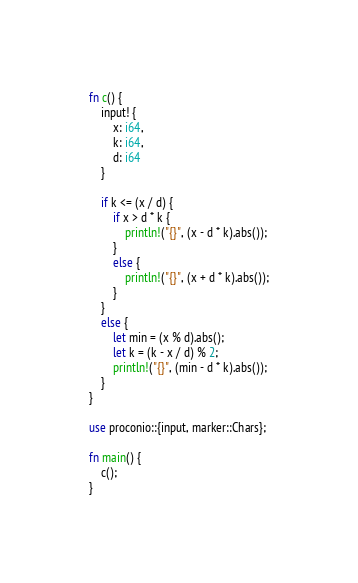Convert code to text. <code><loc_0><loc_0><loc_500><loc_500><_Rust_>fn c() {
    input! {
        x: i64,
        k: i64,
        d: i64
    }

    if k <= (x / d) {
        if x > d * k {
            println!("{}", (x - d * k).abs());
        }
        else {
            println!("{}", (x + d * k).abs());
        }
    }
    else {
        let min = (x % d).abs();
        let k = (k - x / d) % 2;
        println!("{}", (min - d * k).abs());
    }
}

use proconio::{input, marker::Chars};

fn main() {
    c();
}
</code> 